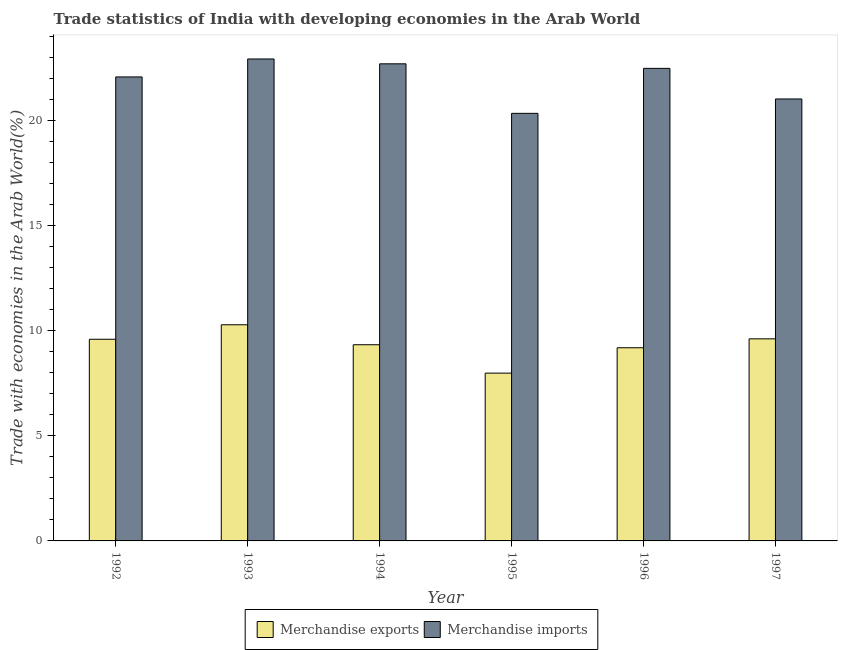How many different coloured bars are there?
Your response must be concise. 2. Are the number of bars on each tick of the X-axis equal?
Offer a very short reply. Yes. How many bars are there on the 2nd tick from the right?
Provide a short and direct response. 2. What is the label of the 6th group of bars from the left?
Offer a very short reply. 1997. In how many cases, is the number of bars for a given year not equal to the number of legend labels?
Make the answer very short. 0. What is the merchandise exports in 1995?
Ensure brevity in your answer.  7.98. Across all years, what is the maximum merchandise exports?
Your answer should be compact. 10.28. Across all years, what is the minimum merchandise exports?
Ensure brevity in your answer.  7.98. In which year was the merchandise imports maximum?
Provide a short and direct response. 1993. In which year was the merchandise exports minimum?
Offer a very short reply. 1995. What is the total merchandise exports in the graph?
Offer a very short reply. 55.96. What is the difference between the merchandise exports in 1992 and that in 1993?
Offer a terse response. -0.69. What is the difference between the merchandise imports in 1996 and the merchandise exports in 1993?
Your answer should be compact. -0.45. What is the average merchandise exports per year?
Make the answer very short. 9.33. What is the ratio of the merchandise imports in 1995 to that in 1996?
Your answer should be very brief. 0.9. Is the merchandise exports in 1993 less than that in 1996?
Keep it short and to the point. No. What is the difference between the highest and the second highest merchandise exports?
Give a very brief answer. 0.67. What is the difference between the highest and the lowest merchandise imports?
Your answer should be very brief. 2.59. In how many years, is the merchandise exports greater than the average merchandise exports taken over all years?
Provide a short and direct response. 4. Is the sum of the merchandise imports in 1992 and 1996 greater than the maximum merchandise exports across all years?
Give a very brief answer. Yes. Are all the bars in the graph horizontal?
Give a very brief answer. No. How many years are there in the graph?
Your answer should be compact. 6. What is the difference between two consecutive major ticks on the Y-axis?
Keep it short and to the point. 5. Does the graph contain grids?
Your answer should be very brief. No. How many legend labels are there?
Offer a very short reply. 2. What is the title of the graph?
Keep it short and to the point. Trade statistics of India with developing economies in the Arab World. What is the label or title of the Y-axis?
Your answer should be compact. Trade with economies in the Arab World(%). What is the Trade with economies in the Arab World(%) in Merchandise exports in 1992?
Provide a short and direct response. 9.59. What is the Trade with economies in the Arab World(%) of Merchandise imports in 1992?
Keep it short and to the point. 22.06. What is the Trade with economies in the Arab World(%) of Merchandise exports in 1993?
Provide a succinct answer. 10.28. What is the Trade with economies in the Arab World(%) of Merchandise imports in 1993?
Give a very brief answer. 22.91. What is the Trade with economies in the Arab World(%) in Merchandise exports in 1994?
Keep it short and to the point. 9.33. What is the Trade with economies in the Arab World(%) of Merchandise imports in 1994?
Keep it short and to the point. 22.68. What is the Trade with economies in the Arab World(%) of Merchandise exports in 1995?
Make the answer very short. 7.98. What is the Trade with economies in the Arab World(%) in Merchandise imports in 1995?
Your answer should be compact. 20.33. What is the Trade with economies in the Arab World(%) of Merchandise exports in 1996?
Give a very brief answer. 9.18. What is the Trade with economies in the Arab World(%) in Merchandise imports in 1996?
Offer a terse response. 22.47. What is the Trade with economies in the Arab World(%) in Merchandise exports in 1997?
Your response must be concise. 9.61. What is the Trade with economies in the Arab World(%) of Merchandise imports in 1997?
Your answer should be compact. 21.01. Across all years, what is the maximum Trade with economies in the Arab World(%) of Merchandise exports?
Offer a terse response. 10.28. Across all years, what is the maximum Trade with economies in the Arab World(%) in Merchandise imports?
Make the answer very short. 22.91. Across all years, what is the minimum Trade with economies in the Arab World(%) in Merchandise exports?
Provide a short and direct response. 7.98. Across all years, what is the minimum Trade with economies in the Arab World(%) in Merchandise imports?
Keep it short and to the point. 20.33. What is the total Trade with economies in the Arab World(%) in Merchandise exports in the graph?
Make the answer very short. 55.96. What is the total Trade with economies in the Arab World(%) in Merchandise imports in the graph?
Give a very brief answer. 131.47. What is the difference between the Trade with economies in the Arab World(%) in Merchandise exports in 1992 and that in 1993?
Provide a short and direct response. -0.69. What is the difference between the Trade with economies in the Arab World(%) in Merchandise imports in 1992 and that in 1993?
Offer a very short reply. -0.85. What is the difference between the Trade with economies in the Arab World(%) of Merchandise exports in 1992 and that in 1994?
Keep it short and to the point. 0.26. What is the difference between the Trade with economies in the Arab World(%) in Merchandise imports in 1992 and that in 1994?
Your answer should be very brief. -0.62. What is the difference between the Trade with economies in the Arab World(%) in Merchandise exports in 1992 and that in 1995?
Offer a very short reply. 1.61. What is the difference between the Trade with economies in the Arab World(%) of Merchandise imports in 1992 and that in 1995?
Keep it short and to the point. 1.73. What is the difference between the Trade with economies in the Arab World(%) in Merchandise exports in 1992 and that in 1996?
Your response must be concise. 0.4. What is the difference between the Trade with economies in the Arab World(%) in Merchandise imports in 1992 and that in 1996?
Ensure brevity in your answer.  -0.41. What is the difference between the Trade with economies in the Arab World(%) of Merchandise exports in 1992 and that in 1997?
Offer a very short reply. -0.02. What is the difference between the Trade with economies in the Arab World(%) of Merchandise imports in 1992 and that in 1997?
Offer a very short reply. 1.05. What is the difference between the Trade with economies in the Arab World(%) of Merchandise exports in 1993 and that in 1994?
Give a very brief answer. 0.95. What is the difference between the Trade with economies in the Arab World(%) of Merchandise imports in 1993 and that in 1994?
Ensure brevity in your answer.  0.23. What is the difference between the Trade with economies in the Arab World(%) of Merchandise exports in 1993 and that in 1995?
Offer a very short reply. 2.3. What is the difference between the Trade with economies in the Arab World(%) in Merchandise imports in 1993 and that in 1995?
Your response must be concise. 2.59. What is the difference between the Trade with economies in the Arab World(%) of Merchandise exports in 1993 and that in 1996?
Offer a terse response. 1.09. What is the difference between the Trade with economies in the Arab World(%) of Merchandise imports in 1993 and that in 1996?
Give a very brief answer. 0.45. What is the difference between the Trade with economies in the Arab World(%) in Merchandise exports in 1993 and that in 1997?
Offer a very short reply. 0.67. What is the difference between the Trade with economies in the Arab World(%) in Merchandise imports in 1993 and that in 1997?
Keep it short and to the point. 1.9. What is the difference between the Trade with economies in the Arab World(%) in Merchandise exports in 1994 and that in 1995?
Your answer should be very brief. 1.35. What is the difference between the Trade with economies in the Arab World(%) in Merchandise imports in 1994 and that in 1995?
Your answer should be compact. 2.36. What is the difference between the Trade with economies in the Arab World(%) in Merchandise exports in 1994 and that in 1996?
Your answer should be compact. 0.14. What is the difference between the Trade with economies in the Arab World(%) in Merchandise imports in 1994 and that in 1996?
Your answer should be very brief. 0.22. What is the difference between the Trade with economies in the Arab World(%) of Merchandise exports in 1994 and that in 1997?
Your answer should be compact. -0.28. What is the difference between the Trade with economies in the Arab World(%) of Merchandise imports in 1994 and that in 1997?
Your answer should be very brief. 1.67. What is the difference between the Trade with economies in the Arab World(%) in Merchandise exports in 1995 and that in 1996?
Your answer should be very brief. -1.21. What is the difference between the Trade with economies in the Arab World(%) in Merchandise imports in 1995 and that in 1996?
Ensure brevity in your answer.  -2.14. What is the difference between the Trade with economies in the Arab World(%) of Merchandise exports in 1995 and that in 1997?
Provide a short and direct response. -1.63. What is the difference between the Trade with economies in the Arab World(%) in Merchandise imports in 1995 and that in 1997?
Offer a very short reply. -0.68. What is the difference between the Trade with economies in the Arab World(%) in Merchandise exports in 1996 and that in 1997?
Ensure brevity in your answer.  -0.42. What is the difference between the Trade with economies in the Arab World(%) in Merchandise imports in 1996 and that in 1997?
Your answer should be very brief. 1.45. What is the difference between the Trade with economies in the Arab World(%) in Merchandise exports in 1992 and the Trade with economies in the Arab World(%) in Merchandise imports in 1993?
Ensure brevity in your answer.  -13.33. What is the difference between the Trade with economies in the Arab World(%) in Merchandise exports in 1992 and the Trade with economies in the Arab World(%) in Merchandise imports in 1994?
Give a very brief answer. -13.1. What is the difference between the Trade with economies in the Arab World(%) in Merchandise exports in 1992 and the Trade with economies in the Arab World(%) in Merchandise imports in 1995?
Offer a terse response. -10.74. What is the difference between the Trade with economies in the Arab World(%) in Merchandise exports in 1992 and the Trade with economies in the Arab World(%) in Merchandise imports in 1996?
Your response must be concise. -12.88. What is the difference between the Trade with economies in the Arab World(%) in Merchandise exports in 1992 and the Trade with economies in the Arab World(%) in Merchandise imports in 1997?
Offer a very short reply. -11.42. What is the difference between the Trade with economies in the Arab World(%) of Merchandise exports in 1993 and the Trade with economies in the Arab World(%) of Merchandise imports in 1994?
Give a very brief answer. -12.41. What is the difference between the Trade with economies in the Arab World(%) of Merchandise exports in 1993 and the Trade with economies in the Arab World(%) of Merchandise imports in 1995?
Make the answer very short. -10.05. What is the difference between the Trade with economies in the Arab World(%) in Merchandise exports in 1993 and the Trade with economies in the Arab World(%) in Merchandise imports in 1996?
Provide a succinct answer. -12.19. What is the difference between the Trade with economies in the Arab World(%) of Merchandise exports in 1993 and the Trade with economies in the Arab World(%) of Merchandise imports in 1997?
Your answer should be compact. -10.74. What is the difference between the Trade with economies in the Arab World(%) in Merchandise exports in 1994 and the Trade with economies in the Arab World(%) in Merchandise imports in 1995?
Give a very brief answer. -11. What is the difference between the Trade with economies in the Arab World(%) of Merchandise exports in 1994 and the Trade with economies in the Arab World(%) of Merchandise imports in 1996?
Provide a short and direct response. -13.14. What is the difference between the Trade with economies in the Arab World(%) of Merchandise exports in 1994 and the Trade with economies in the Arab World(%) of Merchandise imports in 1997?
Make the answer very short. -11.69. What is the difference between the Trade with economies in the Arab World(%) of Merchandise exports in 1995 and the Trade with economies in the Arab World(%) of Merchandise imports in 1996?
Your response must be concise. -14.49. What is the difference between the Trade with economies in the Arab World(%) in Merchandise exports in 1995 and the Trade with economies in the Arab World(%) in Merchandise imports in 1997?
Your response must be concise. -13.04. What is the difference between the Trade with economies in the Arab World(%) in Merchandise exports in 1996 and the Trade with economies in the Arab World(%) in Merchandise imports in 1997?
Give a very brief answer. -11.83. What is the average Trade with economies in the Arab World(%) in Merchandise exports per year?
Offer a terse response. 9.33. What is the average Trade with economies in the Arab World(%) in Merchandise imports per year?
Make the answer very short. 21.91. In the year 1992, what is the difference between the Trade with economies in the Arab World(%) in Merchandise exports and Trade with economies in the Arab World(%) in Merchandise imports?
Provide a short and direct response. -12.47. In the year 1993, what is the difference between the Trade with economies in the Arab World(%) of Merchandise exports and Trade with economies in the Arab World(%) of Merchandise imports?
Your answer should be very brief. -12.64. In the year 1994, what is the difference between the Trade with economies in the Arab World(%) in Merchandise exports and Trade with economies in the Arab World(%) in Merchandise imports?
Your answer should be very brief. -13.36. In the year 1995, what is the difference between the Trade with economies in the Arab World(%) of Merchandise exports and Trade with economies in the Arab World(%) of Merchandise imports?
Your answer should be very brief. -12.35. In the year 1996, what is the difference between the Trade with economies in the Arab World(%) of Merchandise exports and Trade with economies in the Arab World(%) of Merchandise imports?
Offer a very short reply. -13.28. In the year 1997, what is the difference between the Trade with economies in the Arab World(%) of Merchandise exports and Trade with economies in the Arab World(%) of Merchandise imports?
Keep it short and to the point. -11.4. What is the ratio of the Trade with economies in the Arab World(%) in Merchandise exports in 1992 to that in 1993?
Provide a short and direct response. 0.93. What is the ratio of the Trade with economies in the Arab World(%) of Merchandise imports in 1992 to that in 1993?
Your answer should be compact. 0.96. What is the ratio of the Trade with economies in the Arab World(%) in Merchandise exports in 1992 to that in 1994?
Provide a short and direct response. 1.03. What is the ratio of the Trade with economies in the Arab World(%) of Merchandise imports in 1992 to that in 1994?
Provide a short and direct response. 0.97. What is the ratio of the Trade with economies in the Arab World(%) in Merchandise exports in 1992 to that in 1995?
Make the answer very short. 1.2. What is the ratio of the Trade with economies in the Arab World(%) of Merchandise imports in 1992 to that in 1995?
Make the answer very short. 1.09. What is the ratio of the Trade with economies in the Arab World(%) in Merchandise exports in 1992 to that in 1996?
Make the answer very short. 1.04. What is the ratio of the Trade with economies in the Arab World(%) in Merchandise imports in 1992 to that in 1996?
Your answer should be very brief. 0.98. What is the ratio of the Trade with economies in the Arab World(%) in Merchandise imports in 1992 to that in 1997?
Ensure brevity in your answer.  1.05. What is the ratio of the Trade with economies in the Arab World(%) in Merchandise exports in 1993 to that in 1994?
Keep it short and to the point. 1.1. What is the ratio of the Trade with economies in the Arab World(%) of Merchandise imports in 1993 to that in 1994?
Your response must be concise. 1.01. What is the ratio of the Trade with economies in the Arab World(%) in Merchandise exports in 1993 to that in 1995?
Your response must be concise. 1.29. What is the ratio of the Trade with economies in the Arab World(%) of Merchandise imports in 1993 to that in 1995?
Make the answer very short. 1.13. What is the ratio of the Trade with economies in the Arab World(%) in Merchandise exports in 1993 to that in 1996?
Provide a succinct answer. 1.12. What is the ratio of the Trade with economies in the Arab World(%) of Merchandise imports in 1993 to that in 1996?
Your answer should be very brief. 1.02. What is the ratio of the Trade with economies in the Arab World(%) of Merchandise exports in 1993 to that in 1997?
Offer a very short reply. 1.07. What is the ratio of the Trade with economies in the Arab World(%) in Merchandise imports in 1993 to that in 1997?
Provide a succinct answer. 1.09. What is the ratio of the Trade with economies in the Arab World(%) in Merchandise exports in 1994 to that in 1995?
Provide a short and direct response. 1.17. What is the ratio of the Trade with economies in the Arab World(%) in Merchandise imports in 1994 to that in 1995?
Your response must be concise. 1.12. What is the ratio of the Trade with economies in the Arab World(%) in Merchandise exports in 1994 to that in 1996?
Keep it short and to the point. 1.02. What is the ratio of the Trade with economies in the Arab World(%) in Merchandise imports in 1994 to that in 1996?
Give a very brief answer. 1.01. What is the ratio of the Trade with economies in the Arab World(%) in Merchandise exports in 1994 to that in 1997?
Provide a succinct answer. 0.97. What is the ratio of the Trade with economies in the Arab World(%) of Merchandise imports in 1994 to that in 1997?
Keep it short and to the point. 1.08. What is the ratio of the Trade with economies in the Arab World(%) of Merchandise exports in 1995 to that in 1996?
Keep it short and to the point. 0.87. What is the ratio of the Trade with economies in the Arab World(%) in Merchandise imports in 1995 to that in 1996?
Give a very brief answer. 0.9. What is the ratio of the Trade with economies in the Arab World(%) of Merchandise exports in 1995 to that in 1997?
Keep it short and to the point. 0.83. What is the ratio of the Trade with economies in the Arab World(%) in Merchandise imports in 1995 to that in 1997?
Provide a short and direct response. 0.97. What is the ratio of the Trade with economies in the Arab World(%) in Merchandise exports in 1996 to that in 1997?
Your answer should be very brief. 0.96. What is the ratio of the Trade with economies in the Arab World(%) in Merchandise imports in 1996 to that in 1997?
Ensure brevity in your answer.  1.07. What is the difference between the highest and the second highest Trade with economies in the Arab World(%) of Merchandise exports?
Your answer should be very brief. 0.67. What is the difference between the highest and the second highest Trade with economies in the Arab World(%) in Merchandise imports?
Make the answer very short. 0.23. What is the difference between the highest and the lowest Trade with economies in the Arab World(%) in Merchandise exports?
Give a very brief answer. 2.3. What is the difference between the highest and the lowest Trade with economies in the Arab World(%) in Merchandise imports?
Keep it short and to the point. 2.59. 